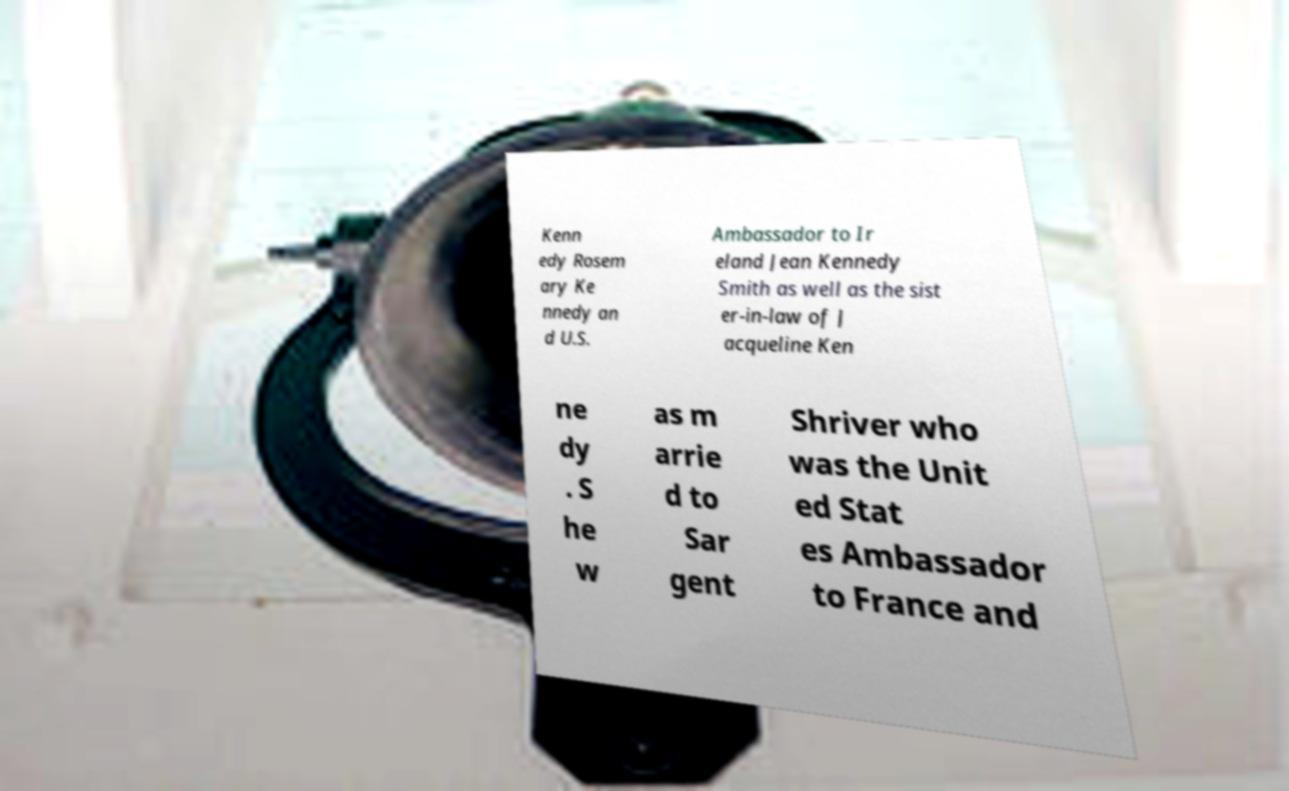For documentation purposes, I need the text within this image transcribed. Could you provide that? Kenn edy Rosem ary Ke nnedy an d U.S. Ambassador to Ir eland Jean Kennedy Smith as well as the sist er-in-law of J acqueline Ken ne dy . S he w as m arrie d to Sar gent Shriver who was the Unit ed Stat es Ambassador to France and 